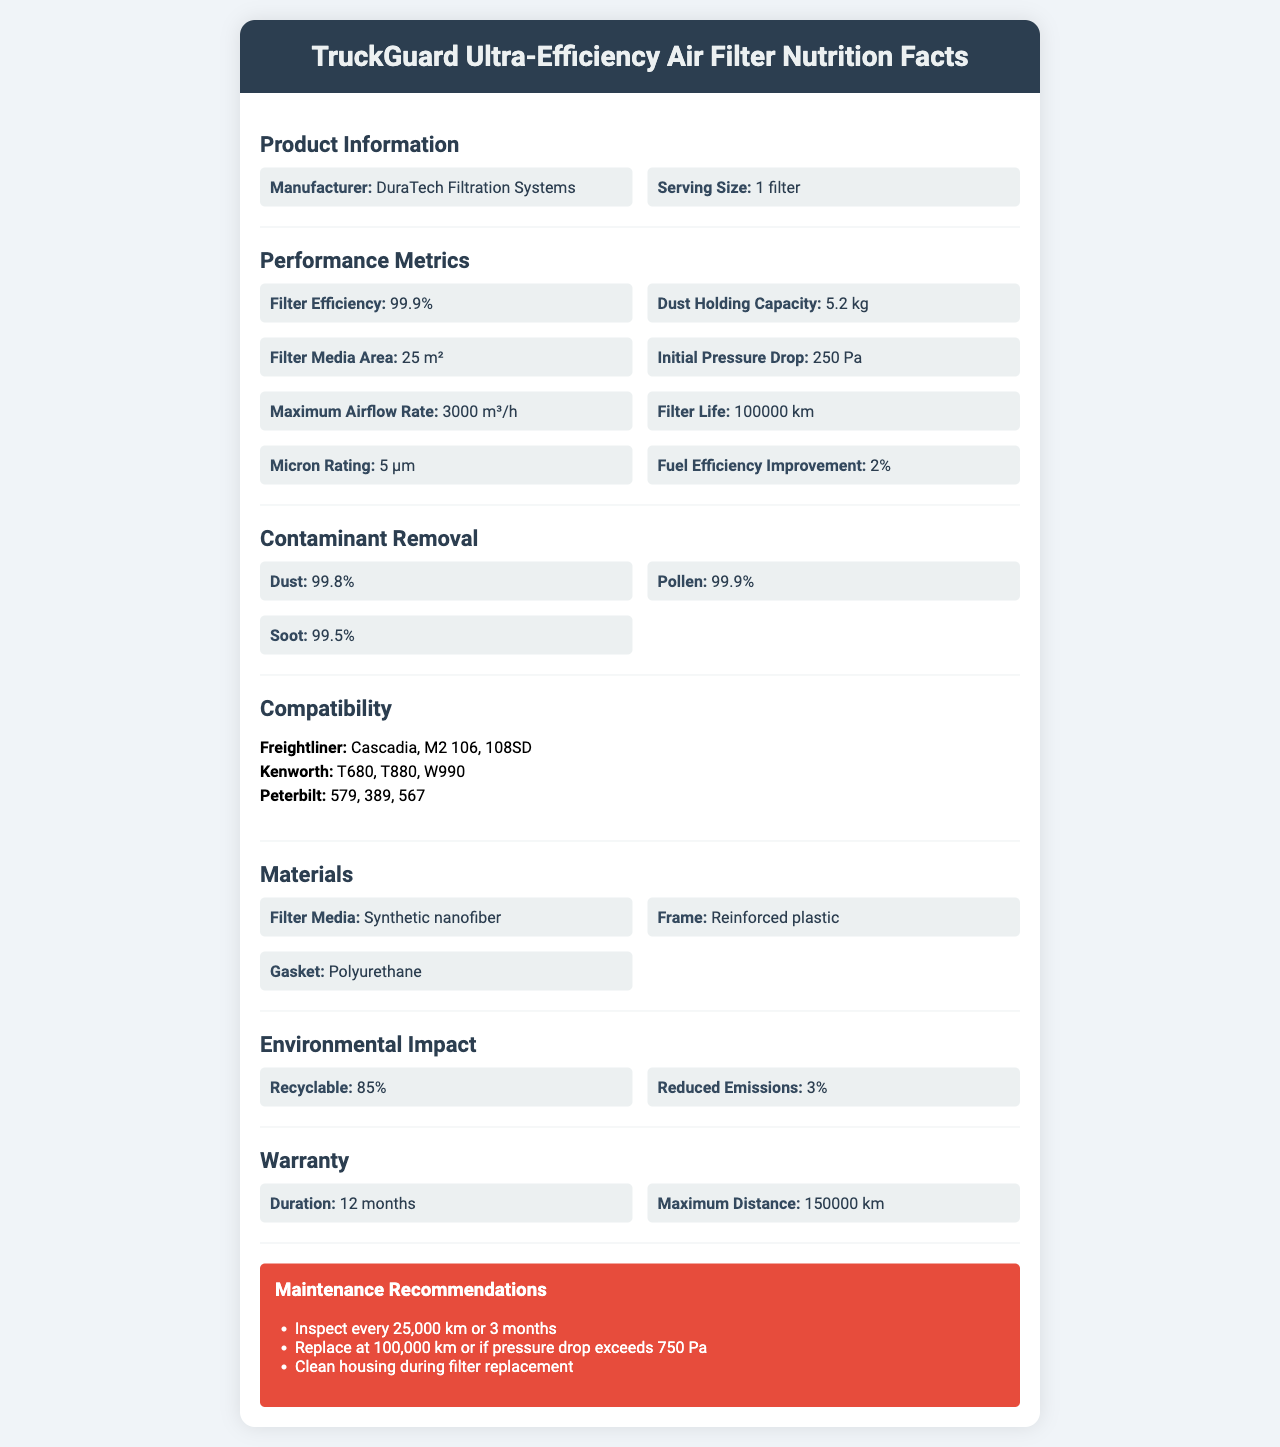What is the filter efficiency of the TruckGuard Ultra-Efficiency Air Filter? The document states that the filter efficiency is 99.9%.
Answer: 99.9% What is the dust holding capacity of this air filter? The dust holding capacity is listed as 5.2 kg in the document.
Answer: 5.2 kg Which truck models are compatible with this air filter? The compatibility section in the document lists compatible models for each truck make.
Answer: Freightliner: Cascadia, M2 106, 108SD; Kenworth: T680, T880, W990; Peterbilt: 579, 389, 567 How often should the TruckGuard Ultra-Efficiency Air Filter be inspected? The maintenance recommendations section advises inspecting the filter every 25,000 km or 3 months.
Answer: Every 25,000 km or 3 months What is the filter life of the TruckGuard Ultra-Efficiency Air Filter in kilometers? The filter life is stated as 100,000 km in the document.
Answer: 100,000 km How much does the TruckGuard Ultra-Efficiency Air Filter improve fuel efficiency? The document mentions a 2% improvement in fuel efficiency.
Answer: 2% What materials are used in the construction of the TruckGuard Ultra-Efficiency Air Filter? A. Metal B. Synthetic nanofiber C. Reinforced plastic D. Polyurethane The materials section states that the filter media is made of synthetic nanofiber, the frame is made of reinforced plastic, and the gasket is made of polyurethane.
Answer: B, C, and D What contaminants does the TruckGuard Ultra-Efficiency Air Filter effectively remove? A. Dust B. Pollen C. Soot D. All of the above The document lists the filter's efficiency in removing dust, pollen, and soot as 99.8%, 99.9%, and 99.5% respectively.
Answer: D Is the TruckGuard Ultra-Efficiency Air Filter recyclable? The environmental impact section says that 85% of the filter is recyclable.
Answer: Yes Summarize the main features and benefits of the TruckGuard Ultra-Efficiency Air Filter. The document provides comprehensive details about the air filter's performance metrics, compatibility, materials, environmental impact, and maintenance recommendations, highlighting its efficiency and benefits.
Answer: The TruckGuard Ultra-Efficiency Air Filter, manufactured by DuraTech Filtration Systems, offers a 99.9% filtration efficiency and holds 5.2 kg of dust. It has a large filter media area of 25 m², an initial pressure drop of 250 Pa, and supports a maximum airflow rate of 3000 m³/h. Compatible with several models from Freightliner, Kenworth, and Peterbilt, it lasts up to 100,000 km before needing a replacement. It improves fuel efficiency by 2% and is made from synthetic nanofiber, reinforced plastic, and polyurethane. Additionally, 85% of it is recyclable, and it comes with a 12-month or 150,000 km warranty. How does the TruckGuard Ultra-Efficiency Air Filter reduce emissions? The document specifies that the filter reduces emissions by 3%.
Answer: 3% What company manufactures the TruckGuard Ultra-Efficiency Air Filter? The manufacturer is listed as DuraTech Filtration Systems in the document.
Answer: DuraTech Filtration Systems What is the maximum pressure drop allowed before needing to replace the filter? The recommendations state that the filter should be replaced if the pressure drop exceeds 750 Pa.
Answer: 750 Pa Who is the target customer for the TruckGuard Ultra-Efficiency Air Filter? The document does not specify the target customer, so it cannot be determined from the provided information.
Answer: Cannot be determined What is the frame of the TruckGuard Ultra-Efficiency Air Filter made of? The materials section states that the frame is made of reinforced plastic.
Answer: Reinforced plastic What is the micron rating of the TruckGuard Ultra-Efficiency Air Filter? The micron rating is specified as 5 µm.
Answer: 5 µm Is the TruckGuard Ultra-Efficiency Air Filter suitable for use in light-duty vehicles? The document only provides compatibility with specific heavy-duty truck models and does not mention light-duty vehicles.
Answer: Not enough information What is the warranty coverage for the TruckGuard Ultra-Efficiency Air Filter in terms of months? The warranty duration is listed as 12 months.
Answer: 12 months Which of the following is NOT a contaminant that the TruckGuard Ultra-Efficiency Air Filter effectively removes? A. Dust B. Pollen C. Oil D. Soot The document lists dust, pollen, and soot as contaminants the filter effectively removes, but does not mention oil.
Answer: C 